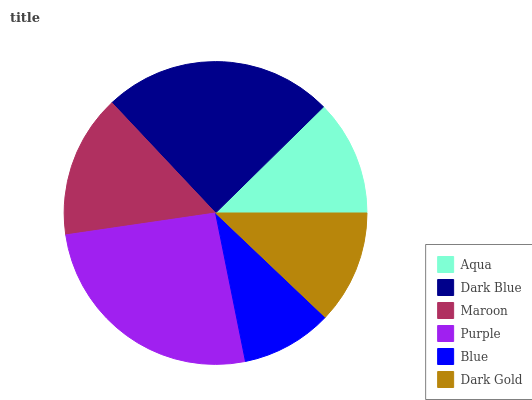Is Blue the minimum?
Answer yes or no. Yes. Is Purple the maximum?
Answer yes or no. Yes. Is Dark Blue the minimum?
Answer yes or no. No. Is Dark Blue the maximum?
Answer yes or no. No. Is Dark Blue greater than Aqua?
Answer yes or no. Yes. Is Aqua less than Dark Blue?
Answer yes or no. Yes. Is Aqua greater than Dark Blue?
Answer yes or no. No. Is Dark Blue less than Aqua?
Answer yes or no. No. Is Maroon the high median?
Answer yes or no. Yes. Is Aqua the low median?
Answer yes or no. Yes. Is Blue the high median?
Answer yes or no. No. Is Dark Gold the low median?
Answer yes or no. No. 